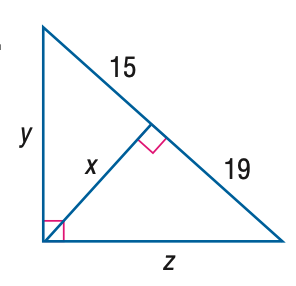Answer the mathemtical geometry problem and directly provide the correct option letter.
Question: Find x.
Choices: A: 15 B: \sqrt { 285 } C: 17 D: 2 \sqrt { 285 } B 